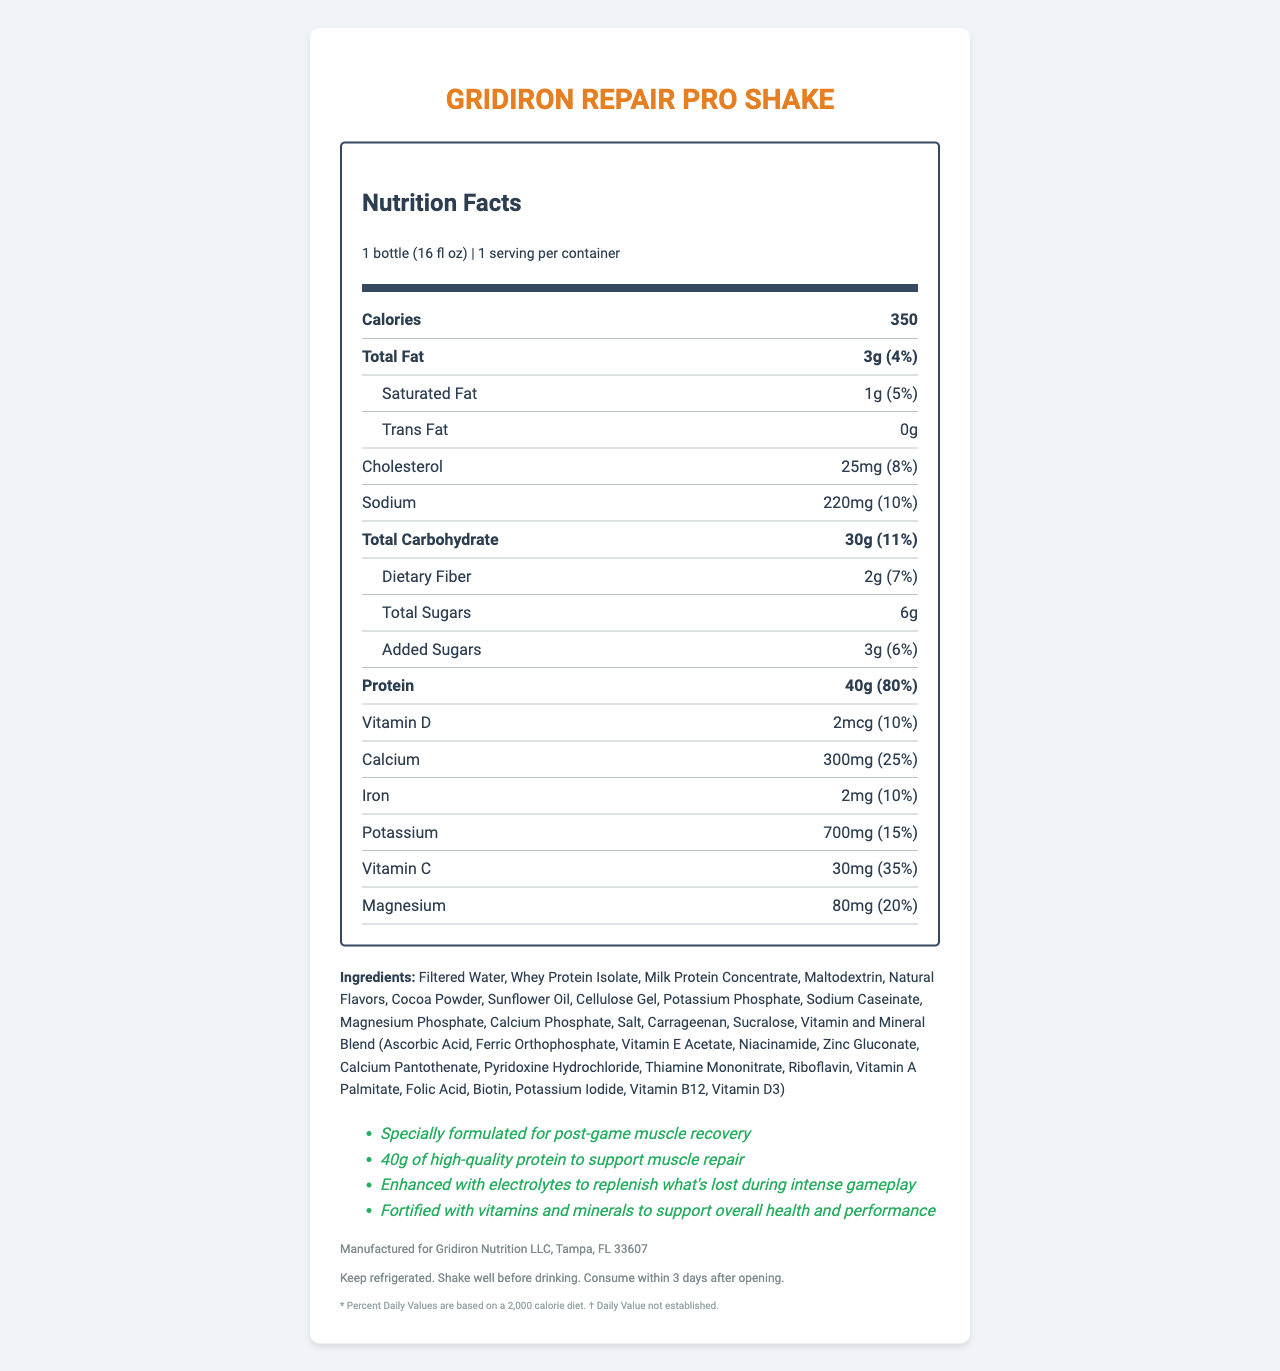what is the serving size of the Gridiron Repair Pro Shake? The serving size is listed directly under the product name as "1 bottle (16 fl oz)".
Answer: 1 bottle (16 fl oz) how many calories are in one serving of the shake? The number of calories is prominently displayed in the "Calories" section of the nutrition facts.
Answer: 350 how much protein does each serving contain? The amount of protein per serving is given as 40g, with a percent daily value of 80%.
Answer: 40g how much added sugar is in the shake? The document states that there are 3g of added sugars, equating to 6% of the daily value.
Answer: 3g what is the main goal of consuming this shake? The product is described as being specially formulated for post-game muscle recovery and muscle repair.
Answer: post-game muscle recovery how much calcium is in one serving? The nutrition facts label indicates that one serving contains 300mg of calcium, which is 25% of the daily value.
Answer: 300mg what allergens are warned about for this shake? The allergen warning clearly states that the product contains milk.
Answer: milk which of the following vitamins is included in the Vitamin and Mineral Blend? A. Vitamin K B. Vitamin E C. Vitamin B1 D. Vitamin B6 The ingredients section lists "Vitamin E Acetate" as part of the Vitamin and Mineral Blend.
Answer: B what is the percent daily value of sodium in one serving? A. 5% B. 6% C. 8% D. 10% The document indicates that one serving contains 220mg of sodium, which equals 10% of the daily value.
Answer: D is the shake suitable for someone with a soy allergy? Although the shake itself does not contain soy, it is produced in a facility that also processes soy, posing a risk for individuals with a soy allergy.
Answer: No what are the necessary storage instructions for the Gridiron Repair Pro Shake? The storage instructions are provided at the end of the document and include keeping the item refrigerated, shaking it well before drinking, and consuming it within 3 days after opening.
Answer: Keep refrigerated. Shake well before drinking. Consume within 3 days after opening. briefly summarize the main features of the Gridiron Repair Pro Shake. This shake is specifically formulated for post-game muscle recovery, offering high protein content and various vitamins and minerals to support overall health and performance.
Answer: The Gridiron Repair Pro Shake is a post-game recovery shake specially designed to aid muscle repair. Each serving provides 350 calories, 40g of protein, and is fortified with key vitamins and minerals. It contains milk and is produced in a facility that also processes soy and egg. The product should be kept refrigerated, shaken well before drinking, and consumed within 3 days after opening. what is the precise source of magnesium in the shake? The document lists "Magnesium Phosphate" but does not provide detailed information on the exact source of magnesium.
Answer: Not enough information 